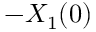<formula> <loc_0><loc_0><loc_500><loc_500>- X _ { 1 } ( 0 )</formula> 